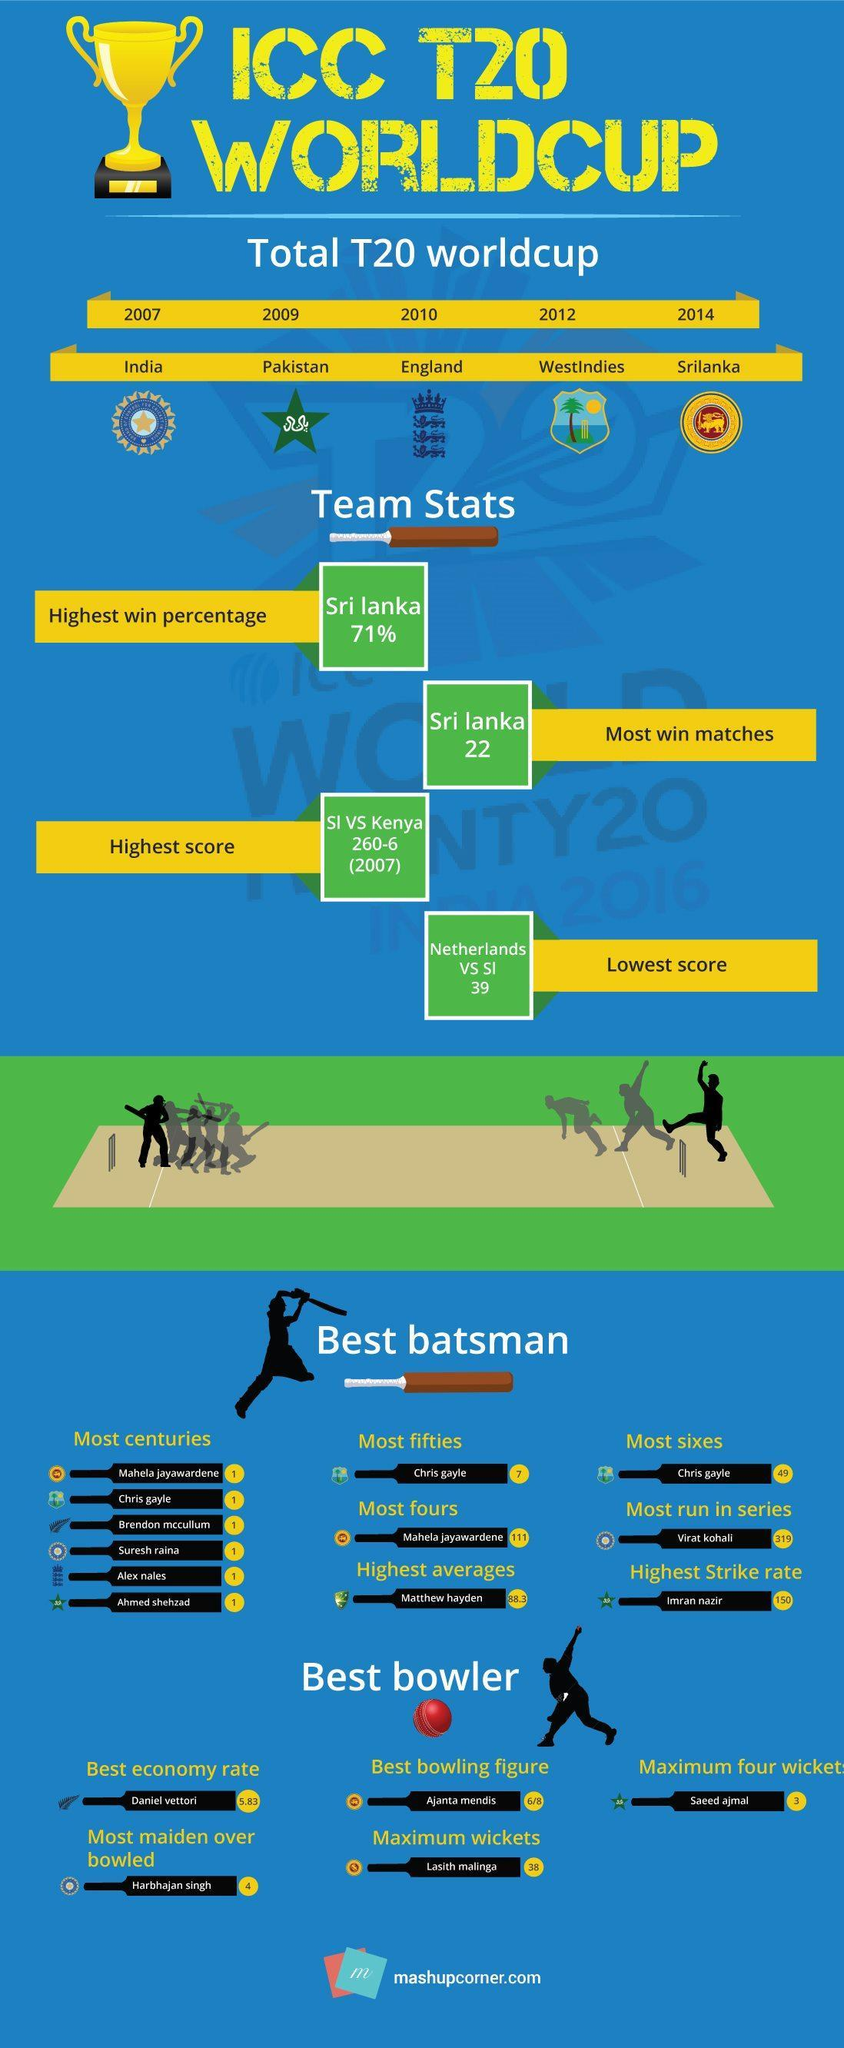Which person has the highest averages?
Answer the question with a short phrase. Matthew hayden Which country is the winner of the T20 World Cup 2012? WestIndies How many T20 Worldcup mentioned in this infographic? 5 Which country is the winner of the T20 World Cup 2010? England Which person has the highest strike rate? Imran nazir 